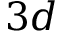<formula> <loc_0><loc_0><loc_500><loc_500>3 d</formula> 